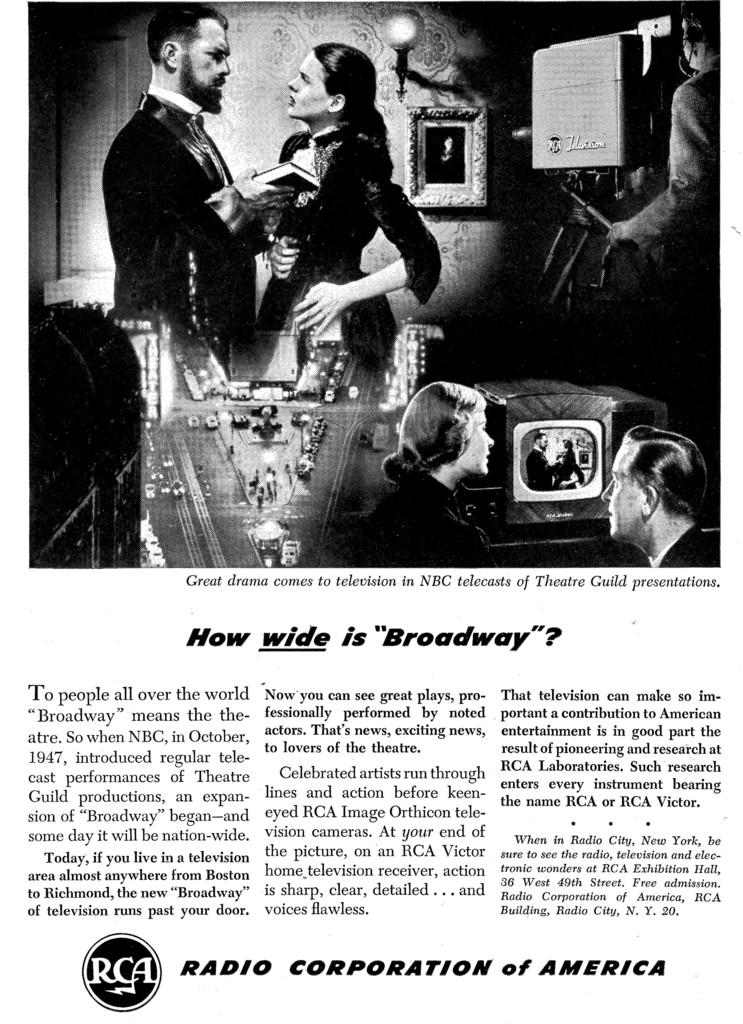What is the source of the image? The image is from an article. What types of people are depicted in the image? There are images of men and women in the picture. Is there any text accompanying the image? Yes, there is a description written below the image. What date is marked on the calendar in the image? There is no calendar present in the image. What type of reaction can be seen on the sign in the image? There is no sign present in the image. 